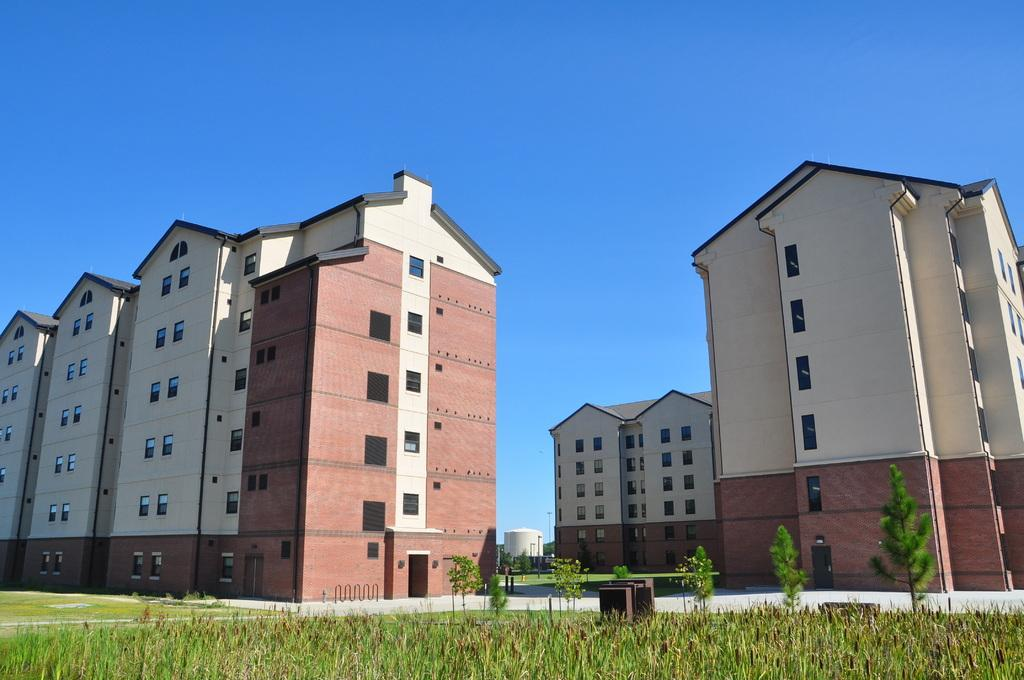What type of structures are present in the image? There are buildings with windows in the image. What can be seen at the bottom of the image? There are plants and grass at the bottom of the image. What is visible in the background of the image? The sky is visible in the background of the image. Can you tell me how many flowers are blooming in the image? There are no flowers present in the image; it features buildings, plants, grass, and the sky. Is there a volcano erupting in the image? There is no volcano present in the image. 